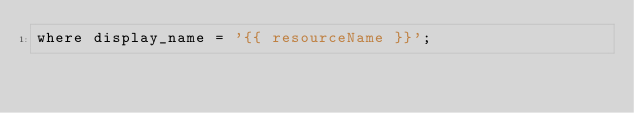<code> <loc_0><loc_0><loc_500><loc_500><_SQL_>where display_name = '{{ resourceName }}';</code> 